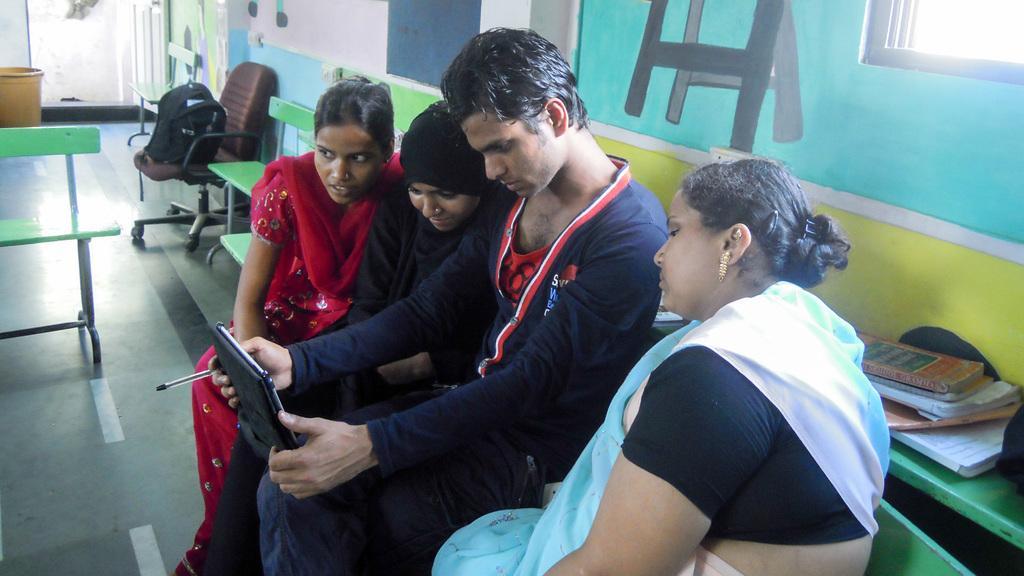Can you describe this image briefly? In this image, we can see four people are sitting on the bench. Here a person is holding an iPad and pen. Background we can see paintings on the wall. Here we can see chair, backpack, bucket, few books, door and floor. 